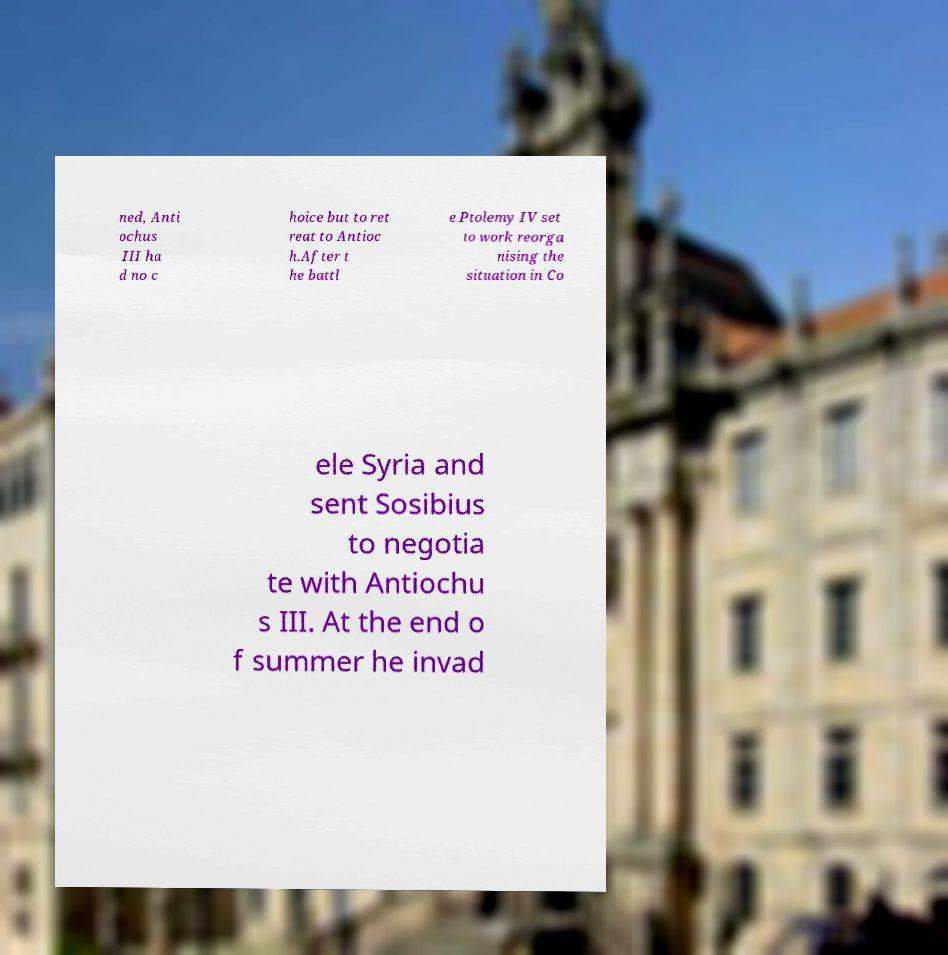Can you accurately transcribe the text from the provided image for me? ned, Anti ochus III ha d no c hoice but to ret reat to Antioc h.After t he battl e Ptolemy IV set to work reorga nising the situation in Co ele Syria and sent Sosibius to negotia te with Antiochu s III. At the end o f summer he invad 